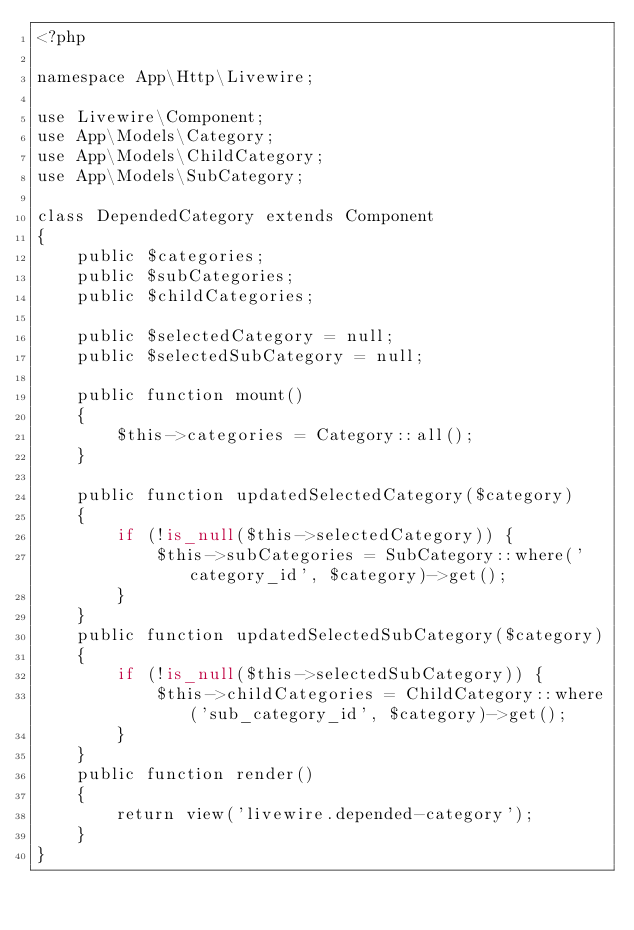Convert code to text. <code><loc_0><loc_0><loc_500><loc_500><_PHP_><?php

namespace App\Http\Livewire;

use Livewire\Component;
use App\Models\Category;
use App\Models\ChildCategory;
use App\Models\SubCategory;

class DependedCategory extends Component
{
    public $categories;
    public $subCategories;
    public $childCategories;

    public $selectedCategory = null;
    public $selectedSubCategory = null;

    public function mount()
    {
        $this->categories = Category::all();
    }

    public function updatedSelectedCategory($category)
    {
        if (!is_null($this->selectedCategory)) {
            $this->subCategories = SubCategory::where('category_id', $category)->get();
        }
    }
    public function updatedSelectedSubCategory($category)
    {
        if (!is_null($this->selectedSubCategory)) {
            $this->childCategories = ChildCategory::where('sub_category_id', $category)->get();
        }
    }
    public function render()
    {
        return view('livewire.depended-category');
    }
}
</code> 